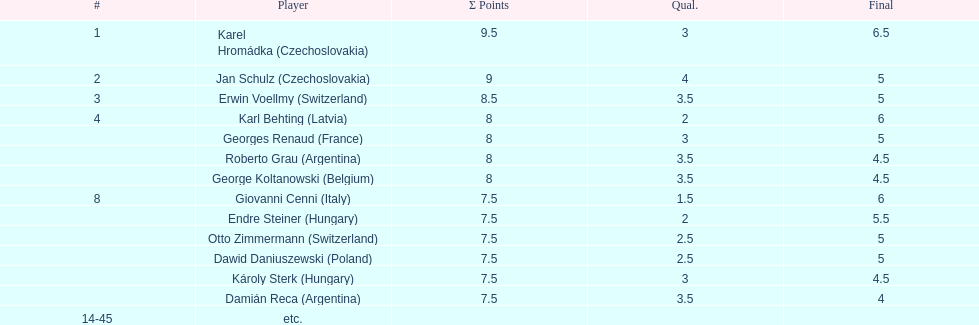What were the concluding scores for karl behting and giovanni cenni? 6. 